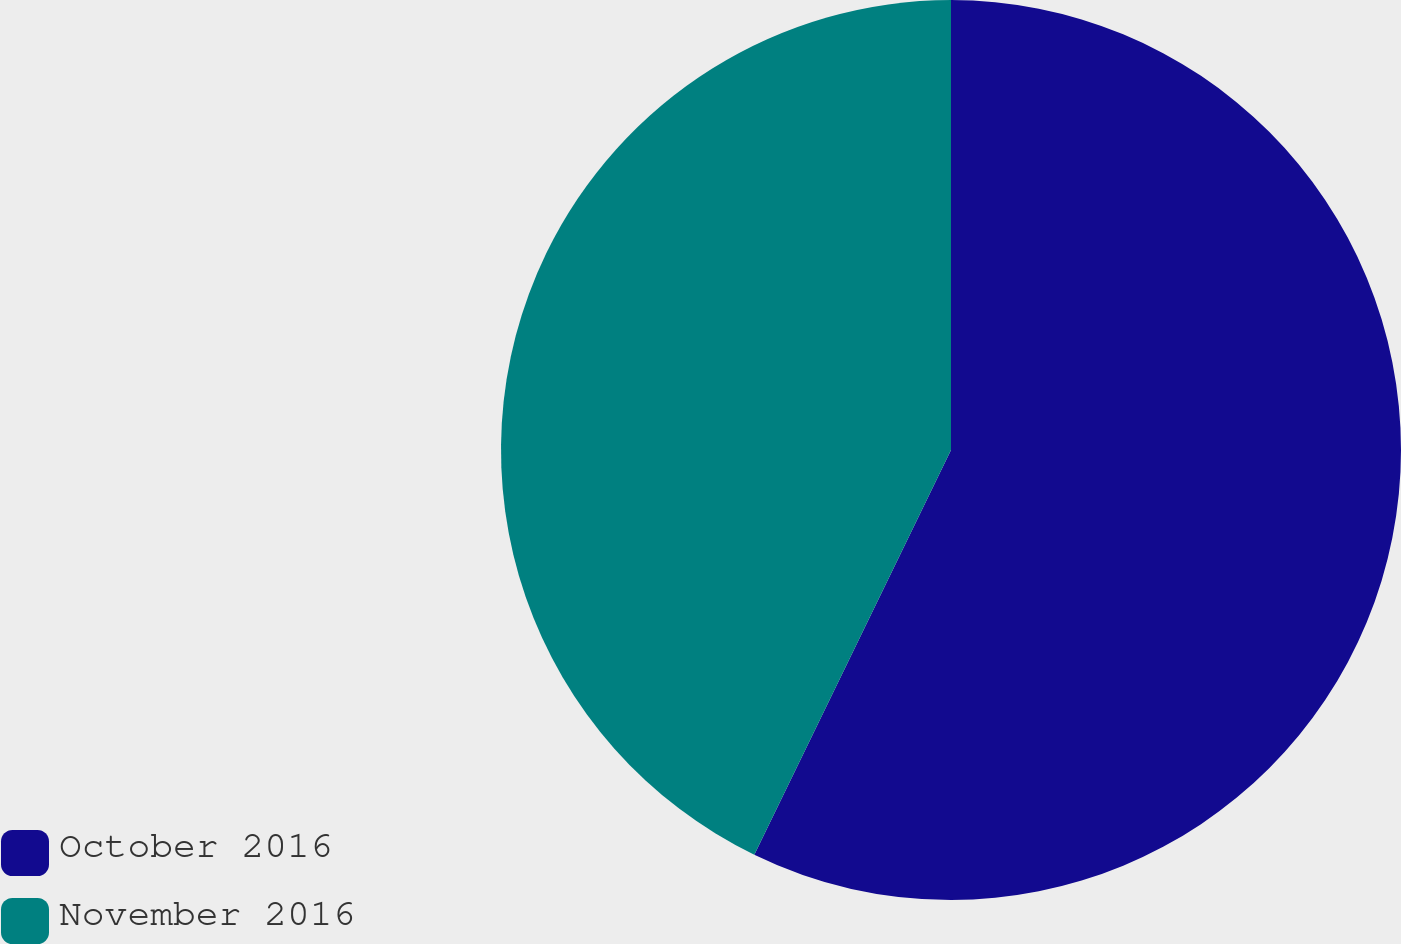Convert chart. <chart><loc_0><loc_0><loc_500><loc_500><pie_chart><fcel>October 2016<fcel>November 2016<nl><fcel>57.2%<fcel>42.8%<nl></chart> 